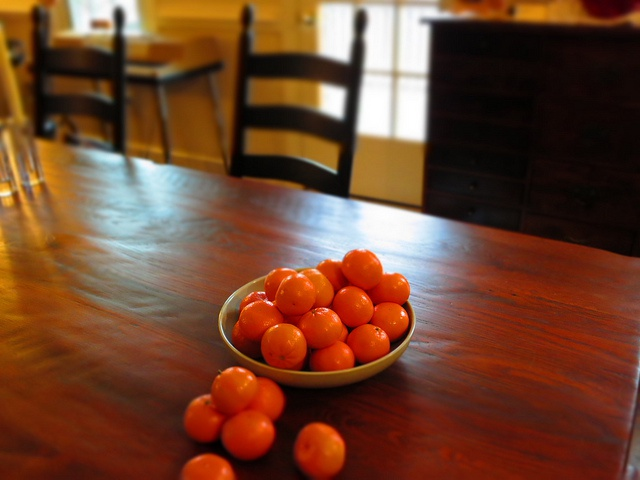Describe the objects in this image and their specific colors. I can see dining table in orange, maroon, brown, and darkgray tones, bowl in orange, brown, red, and maroon tones, chair in orange, black, olive, and maroon tones, chair in orange, black, maroon, and gray tones, and orange in orange, brown, red, and maroon tones in this image. 